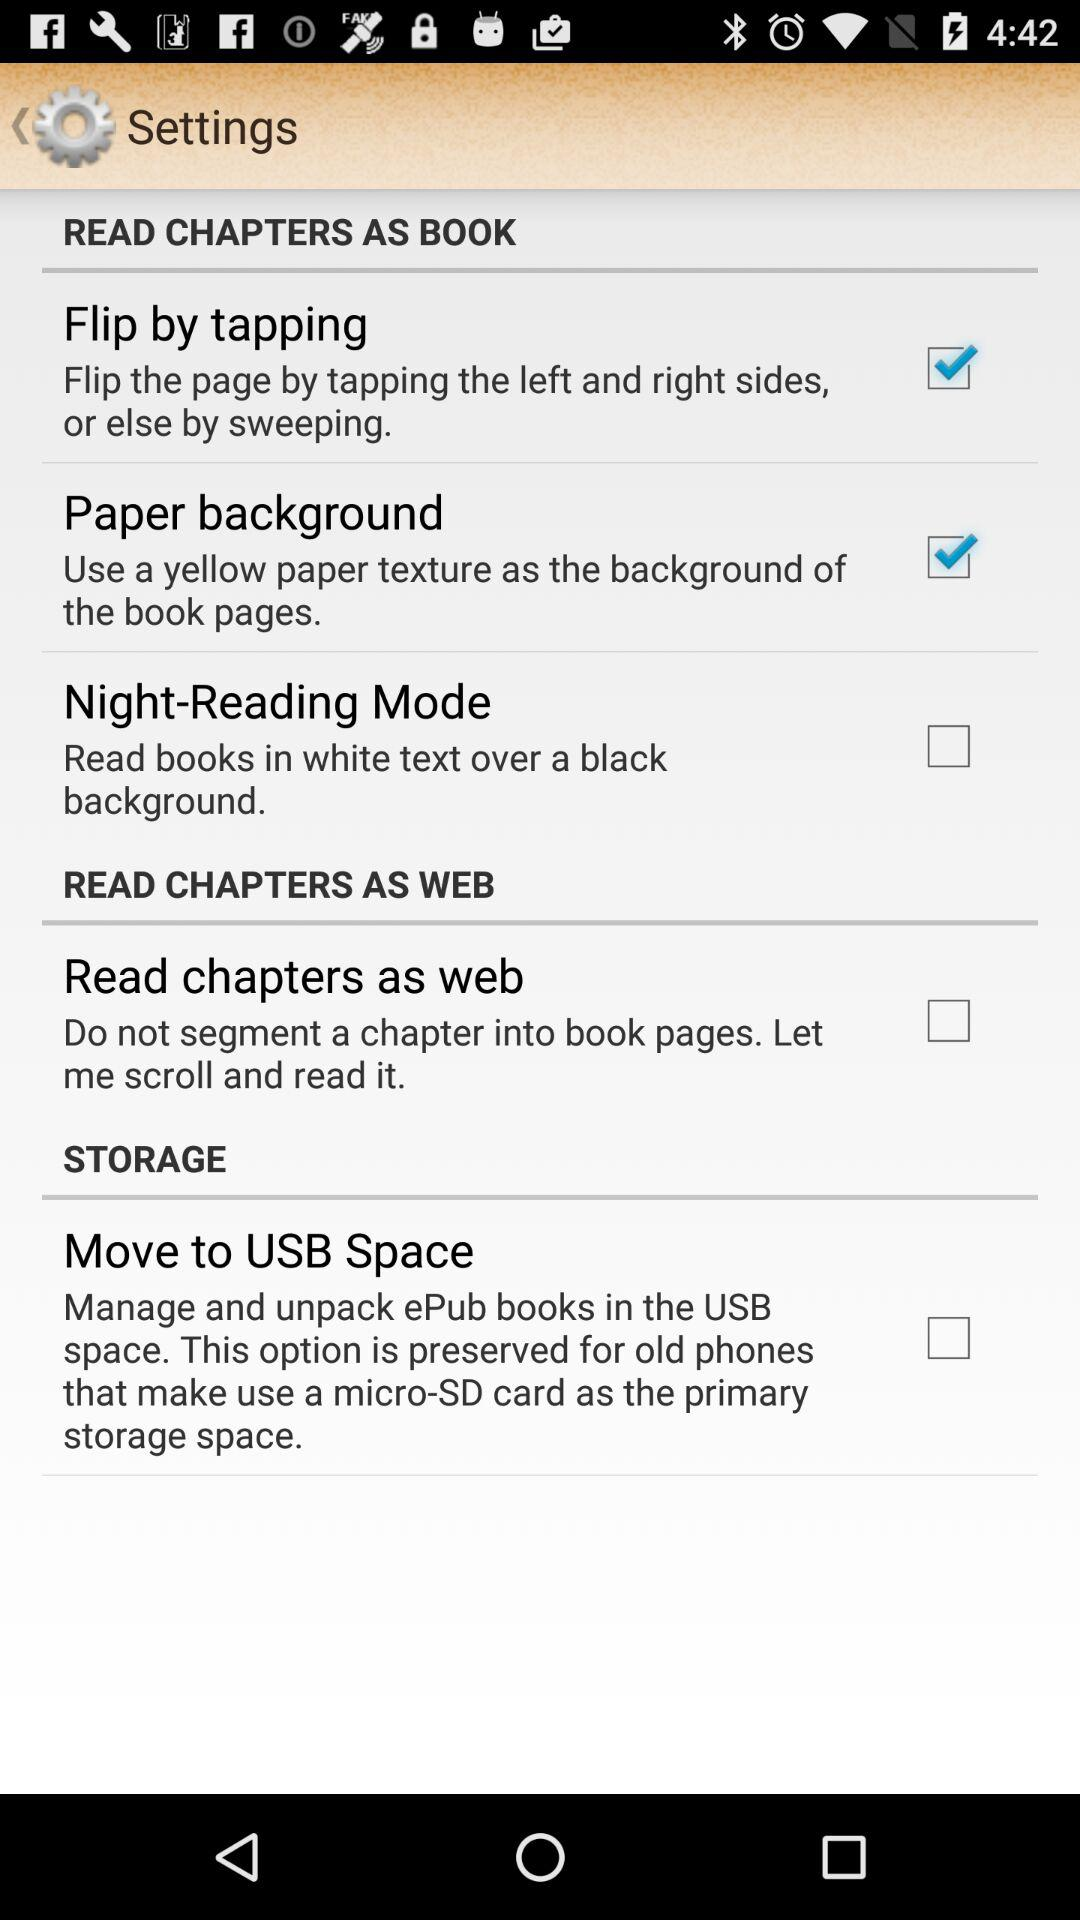What is the status of "Flip by tapping"? The status is "on". 